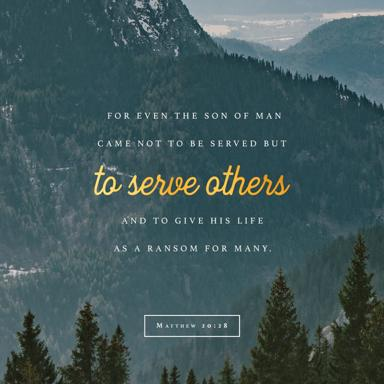Is this quote related to any specific work or belief? Indeed, the quote is deeply tied to Christian doctrine. It's extracted from the Gospel of Matthew in the Bible, specifically from chapter 20, verse 28. It reflects a core Christian belief in the humility and sacrificial role of Jesus Christ, emphasizing his purpose of serving others rather than being served, culminating in his ultimate sacrifice for human redemption. 